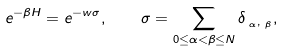Convert formula to latex. <formula><loc_0><loc_0><loc_500><loc_500>e ^ { - \beta H } = e ^ { - w \sigma } , \quad \sigma = \sum _ { 0 \leq \alpha < \beta \leq N } \delta _ { { \mathbf r } _ { \alpha } , { \mathbf r } _ { \beta } } ,</formula> 